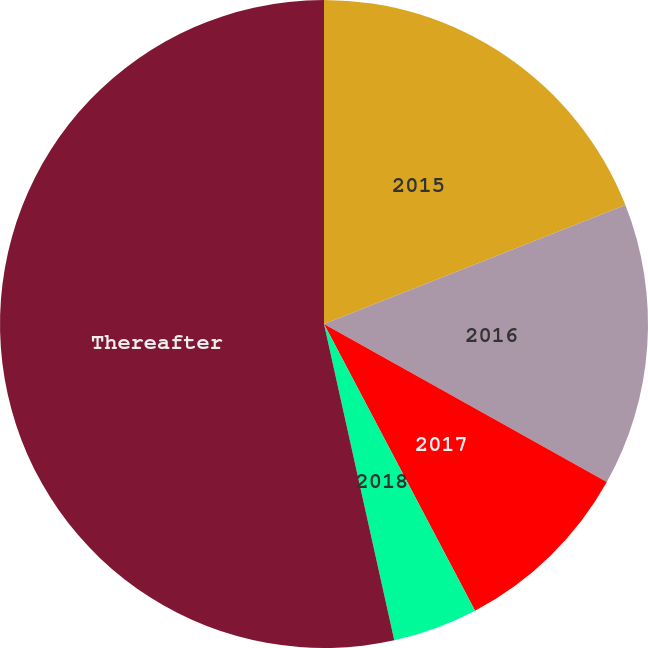Convert chart to OTSL. <chart><loc_0><loc_0><loc_500><loc_500><pie_chart><fcel>2015<fcel>2016<fcel>2017<fcel>2018<fcel>Thereafter<nl><fcel>19.02%<fcel>14.09%<fcel>9.17%<fcel>4.24%<fcel>53.48%<nl></chart> 